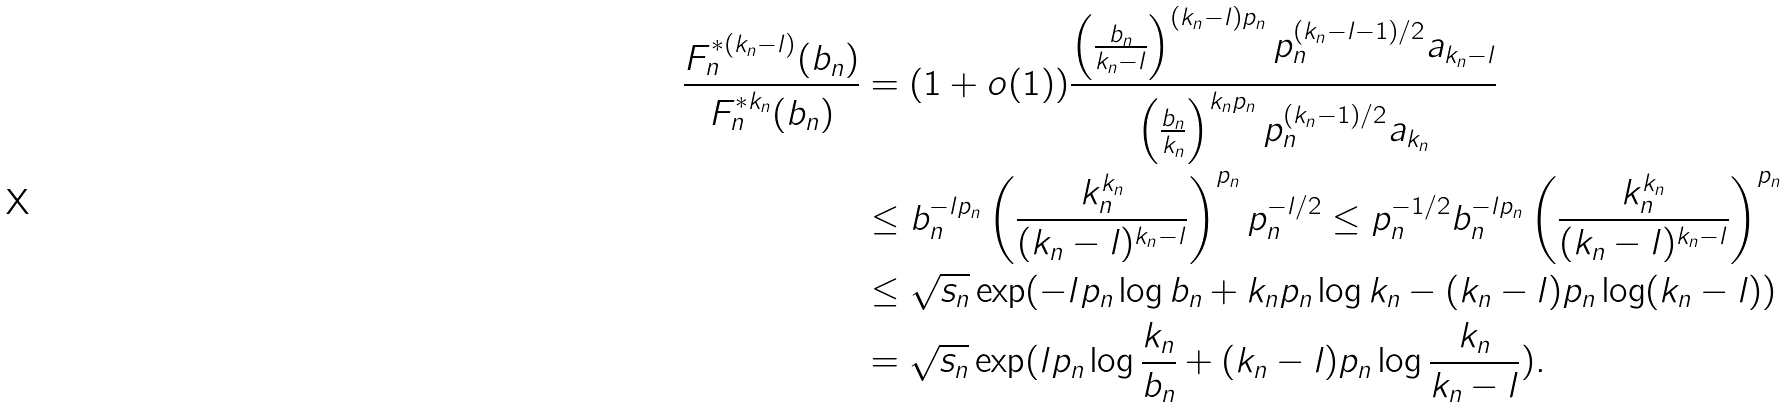<formula> <loc_0><loc_0><loc_500><loc_500>\frac { F ^ { * ( k _ { n } - l ) } _ { n } ( b _ { n } ) } { F ^ { * k _ { n } } _ { n } ( b _ { n } ) } & = ( 1 + o ( 1 ) ) \frac { \left ( \frac { b _ { n } } { k _ { n } - l } \right ) ^ { ( k _ { n } - l ) p _ { n } } p _ { n } ^ { ( k _ { n } - l - 1 ) / 2 } a _ { k _ { n } - l } } { \left ( \frac { b _ { n } } { k _ { n } } \right ) ^ { k _ { n } p _ { n } } p _ { n } ^ { ( k _ { n } - 1 ) / 2 } a _ { k _ { n } } } \\ & \leq b _ { n } ^ { - l p _ { n } } \left ( \frac { k _ { n } ^ { k _ { n } } } { ( k _ { n } - l ) ^ { k _ { n } - l } } \right ) ^ { p _ { n } } p _ { n } ^ { - l / 2 } \leq p _ { n } ^ { - 1 / 2 } b _ { n } ^ { - l p _ { n } } \left ( \frac { k _ { n } ^ { k _ { n } } } { ( k _ { n } - l ) ^ { k _ { n } - l } } \right ) ^ { p _ { n } } \\ & \leq \sqrt { s _ { n } } \exp ( - l p _ { n } \log b _ { n } + k _ { n } p _ { n } \log k _ { n } - ( k _ { n } - l ) p _ { n } \log ( k _ { n } - l ) ) \\ & = \sqrt { s _ { n } } \exp ( l p _ { n } \log \frac { k _ { n } } { b _ { n } } + ( k _ { n } - l ) p _ { n } \log \frac { k _ { n } } { k _ { n } - l } ) .</formula> 